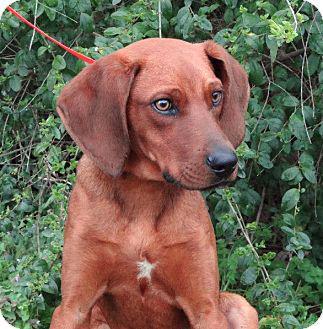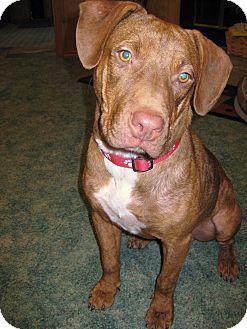The first image is the image on the left, the second image is the image on the right. Analyze the images presented: Is the assertion "There are two dogs in the left image." valid? Answer yes or no. No. The first image is the image on the left, the second image is the image on the right. Assess this claim about the two images: "There is a total of three dogs.". Correct or not? Answer yes or no. No. 